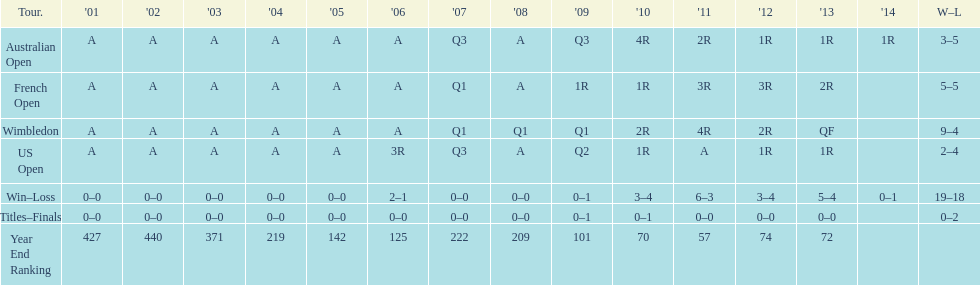How many tournaments had 5 total losses? 2. 